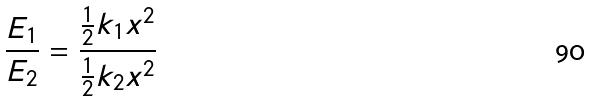<formula> <loc_0><loc_0><loc_500><loc_500>\frac { E _ { 1 } } { E _ { 2 } } = \frac { \frac { 1 } { 2 } k _ { 1 } x ^ { 2 } } { \frac { 1 } { 2 } k _ { 2 } x ^ { 2 } }</formula> 